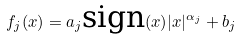<formula> <loc_0><loc_0><loc_500><loc_500>f _ { j } ( x ) = a _ { j } \text {sign} ( x ) | x | ^ { \alpha _ { j } } + b _ { j }</formula> 